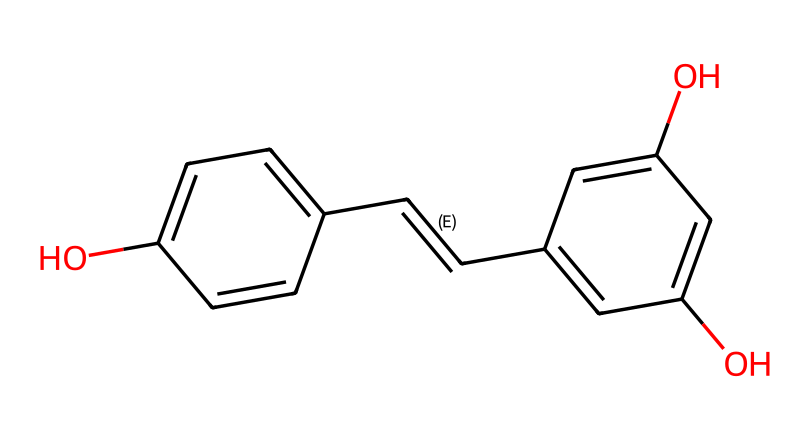What is the molecular formula of resveratrol? To determine the molecular formula, count the number of each type of atom in the SMILES representation. The structure contains 14 carbon atoms, 12 hydrogen atoms, and 4 oxygen atoms, giving the formula C14H12O4.
Answer: C14H12O4 How many hydroxyl (–OH) groups are present in resveratrol? By analyzing the SMILES representation, two hydroxyl (–OH) groups are observed on the aromatic rings, indicating the presence of two –OH groups.
Answer: 2 What type of chemical bond connects the carbon atoms in resveratrol? In the SMILES representation, single bonds and a double bond are indicated. The presence of C=C denotes a double bond between the carbon atoms, while other connections represent single bonds.
Answer: single and double bonds What functional groups are present in resveratrol? By examining the chemical structure, the hydroxyl (–OH) and olefinic (C=C) functional groups can be identified, which are characteristic of resveratrol.
Answer: hydroxyl and olefinic How many aromatic rings are in the structure of resveratrol? The chemical structure reveals the presence of two distinct aromatic rings, which can be inferred from the cyclic arrangements of carbon atoms with alternating double bonds.
Answer: 2 What is the role of resveratrol as a chemical? Resveratrol acts as an antioxidant due to its ability to scavenge free radicals, thereby protecting cells from oxidative stress, as suggested by its chemical composition that allows for electron donation.
Answer: antioxidant 